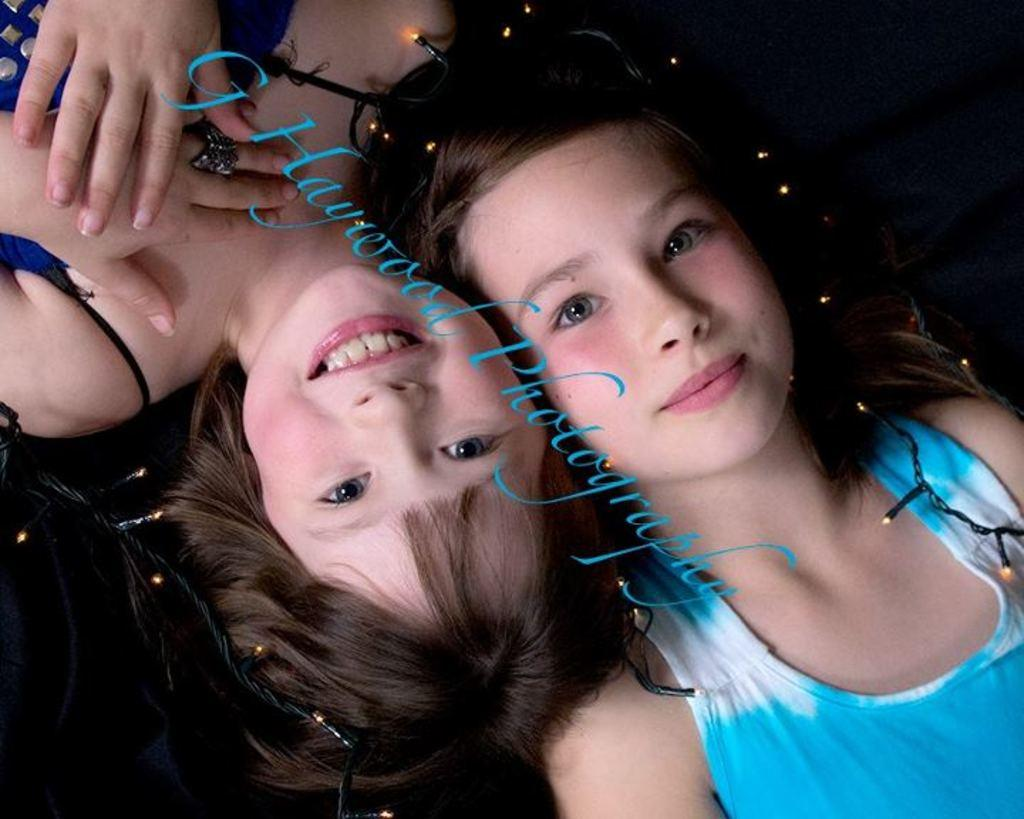How many people are in the image? There are two girls in the image. What are the girls doing in the image? The girls are lying on the bed. What expression do the girls have in the image? The girls are smiling. What type of image is it? The image is an edited picture. What can be seen in the middle of the image? There is text in the middle of the image. What is present on the bed with the girls? There are lights on the bed. What type of hobbies do the girls have in the image? There is no information about the girls' hobbies in the image. Can you tell me how many lamps are present in the image? The image only mentions "lights" on the bed, not specifically "lamps." 